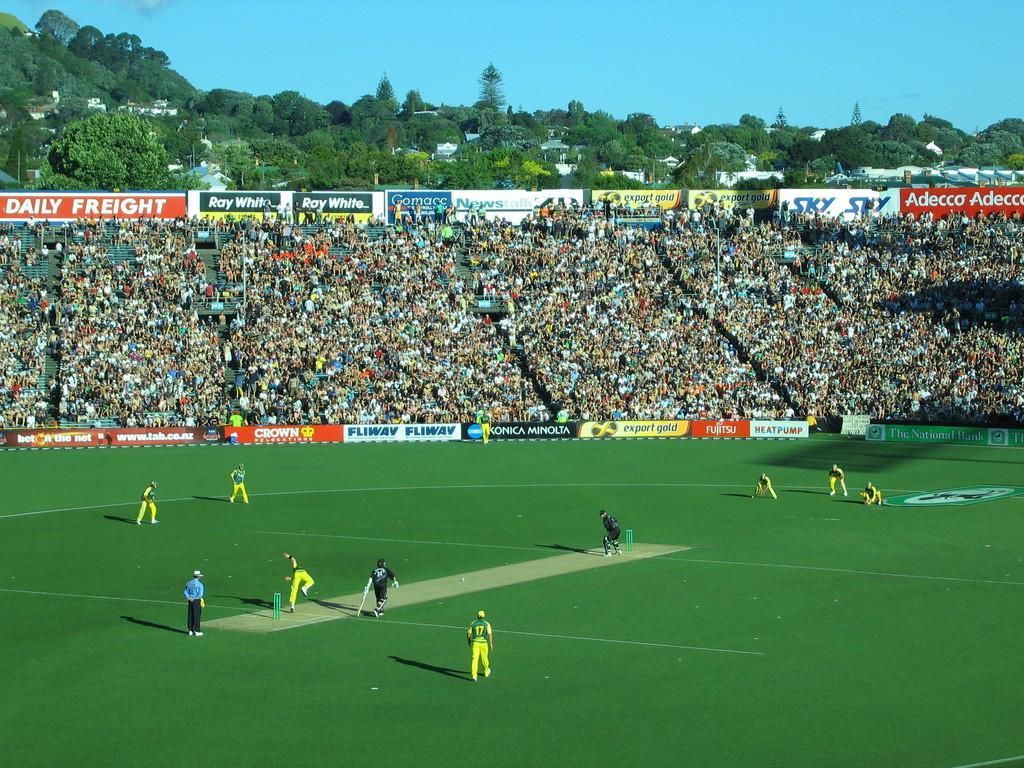In one or two sentences, can you explain what this image depicts? In this image we can see the cricket stadium, some people are playing cricket on the ground, some banners with text, some people are holding objects, some people are standing, some objects on the ground, some people are sitting, some houses, some poles, some trees, bushes, plants and grass on the ground. At the top there is the sky. 